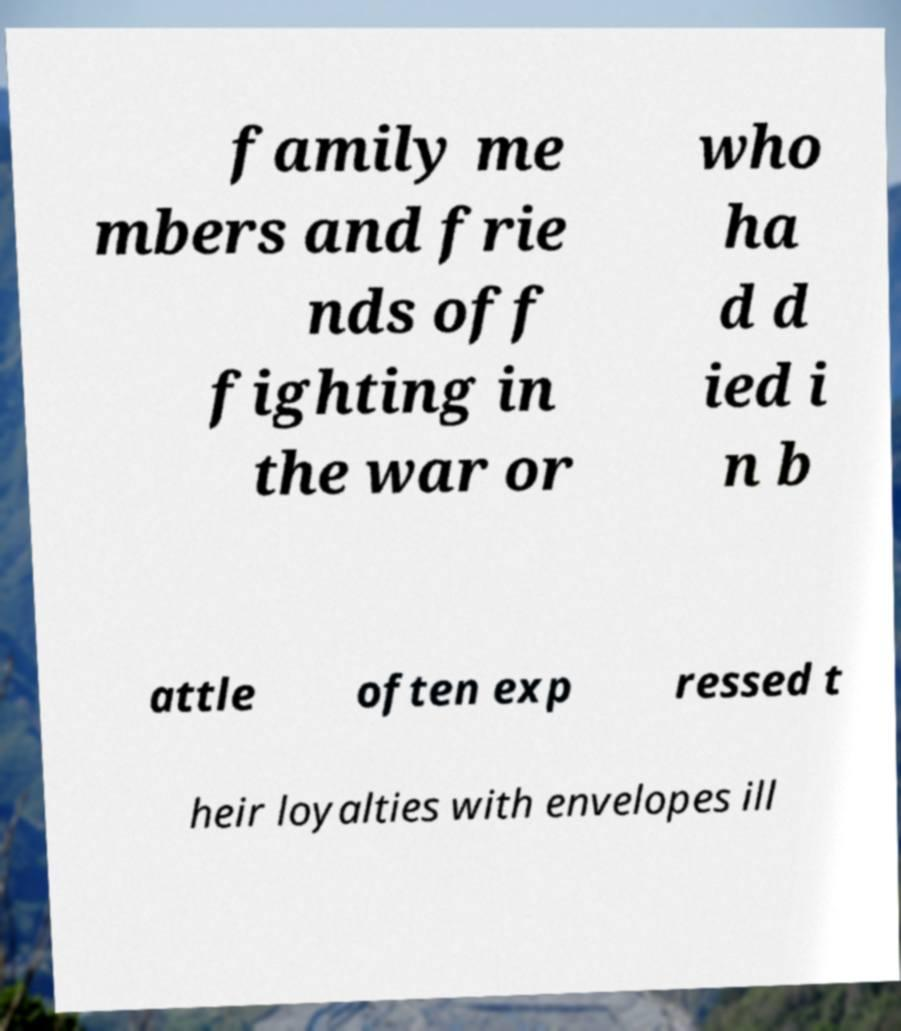What messages or text are displayed in this image? I need them in a readable, typed format. family me mbers and frie nds off fighting in the war or who ha d d ied i n b attle often exp ressed t heir loyalties with envelopes ill 